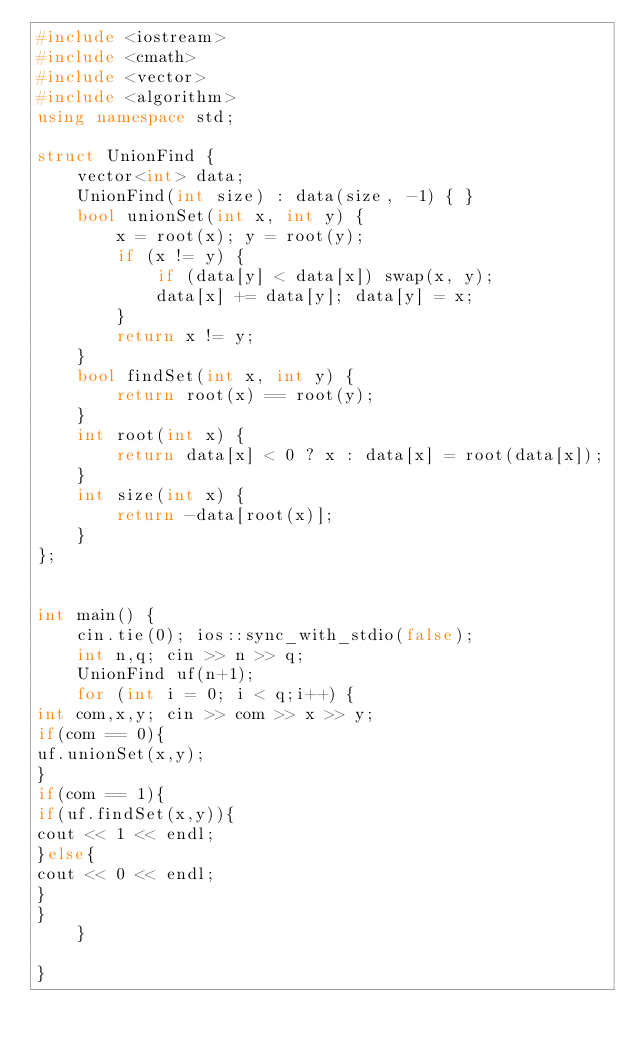Convert code to text. <code><loc_0><loc_0><loc_500><loc_500><_C++_>#include <iostream>
#include <cmath>
#include <vector>
#include <algorithm>
using namespace std;
 
struct UnionFind {
    vector<int> data;
    UnionFind(int size) : data(size, -1) { }
    bool unionSet(int x, int y) {
        x = root(x); y = root(y);
        if (x != y) {
            if (data[y] < data[x]) swap(x, y);
            data[x] += data[y]; data[y] = x;
        }
        return x != y;
    }
    bool findSet(int x, int y) {
        return root(x) == root(y);
    }
    int root(int x) {
        return data[x] < 0 ? x : data[x] = root(data[x]);
    }
    int size(int x) {
        return -data[root(x)];
    }
};
 
 
int main() {
    cin.tie(0); ios::sync_with_stdio(false);
    int n,q; cin >> n >> q; 
    UnionFind uf(n+1);
    for (int i = 0; i < q;i++) {
int com,x,y; cin >> com >> x >> y;
if(com == 0){
uf.unionSet(x,y);
}
if(com == 1){
if(uf.findSet(x,y)){
cout << 1 << endl;
}else{
cout << 0 << endl;
}
}
    }
 
}</code> 